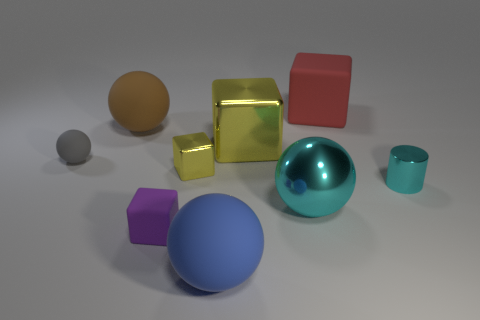How many big blue balls have the same material as the small purple cube?
Offer a very short reply. 1. What is the shape of the object that is the same color as the tiny cylinder?
Your response must be concise. Sphere. Are there any other big cyan metal things of the same shape as the big cyan thing?
Give a very brief answer. No. What shape is the cyan object that is the same size as the brown object?
Keep it short and to the point. Sphere. Does the large metallic block have the same color as the object to the right of the red matte block?
Ensure brevity in your answer.  No. What number of small yellow shiny cubes are on the left side of the brown rubber ball that is behind the cyan cylinder?
Provide a short and direct response. 0. There is a matte object that is to the right of the purple rubber cube and in front of the large yellow shiny thing; what size is it?
Give a very brief answer. Large. Is there a brown rubber sphere of the same size as the gray ball?
Ensure brevity in your answer.  No. Are there more large red things in front of the large yellow metal thing than big metal things behind the red cube?
Your answer should be compact. No. Is the red block made of the same material as the big ball that is behind the tiny cyan metallic cylinder?
Give a very brief answer. Yes. 